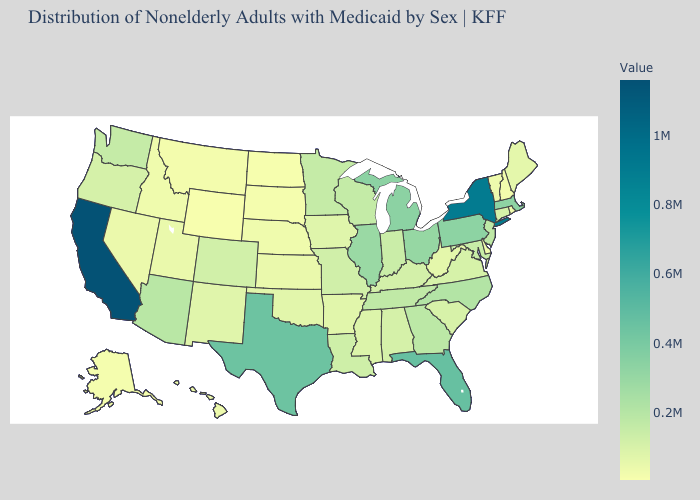Among the states that border Connecticut , does New York have the highest value?
Keep it brief. Yes. Does California have the highest value in the USA?
Keep it brief. Yes. Among the states that border Vermont , does Massachusetts have the lowest value?
Concise answer only. No. Does Wyoming have the lowest value in the USA?
Be succinct. Yes. 